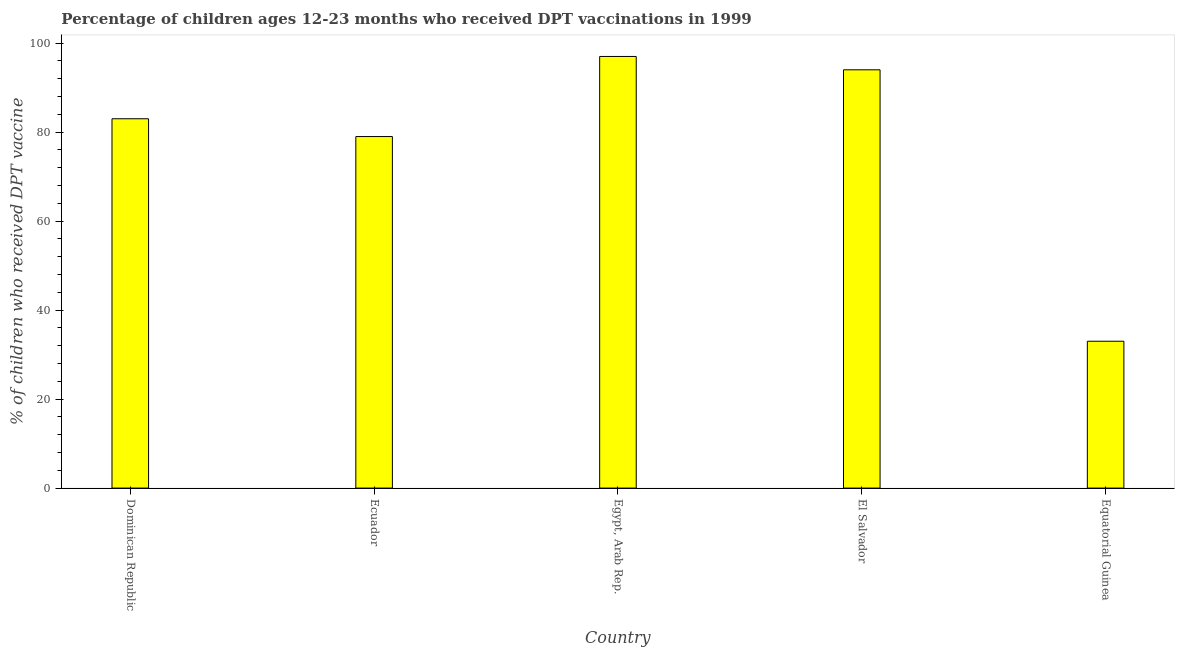Does the graph contain any zero values?
Make the answer very short. No. Does the graph contain grids?
Provide a short and direct response. No. What is the title of the graph?
Your answer should be very brief. Percentage of children ages 12-23 months who received DPT vaccinations in 1999. What is the label or title of the Y-axis?
Your answer should be compact. % of children who received DPT vaccine. What is the percentage of children who received dpt vaccine in Dominican Republic?
Offer a very short reply. 83. Across all countries, what is the maximum percentage of children who received dpt vaccine?
Make the answer very short. 97. Across all countries, what is the minimum percentage of children who received dpt vaccine?
Offer a very short reply. 33. In which country was the percentage of children who received dpt vaccine maximum?
Your answer should be compact. Egypt, Arab Rep. In which country was the percentage of children who received dpt vaccine minimum?
Make the answer very short. Equatorial Guinea. What is the sum of the percentage of children who received dpt vaccine?
Make the answer very short. 386. What is the average percentage of children who received dpt vaccine per country?
Offer a very short reply. 77.2. What is the ratio of the percentage of children who received dpt vaccine in Dominican Republic to that in Ecuador?
Your response must be concise. 1.05. Is the percentage of children who received dpt vaccine in Egypt, Arab Rep. less than that in El Salvador?
Keep it short and to the point. No. Is the sum of the percentage of children who received dpt vaccine in Ecuador and Egypt, Arab Rep. greater than the maximum percentage of children who received dpt vaccine across all countries?
Your response must be concise. Yes. In how many countries, is the percentage of children who received dpt vaccine greater than the average percentage of children who received dpt vaccine taken over all countries?
Provide a succinct answer. 4. Are all the bars in the graph horizontal?
Keep it short and to the point. No. What is the difference between two consecutive major ticks on the Y-axis?
Ensure brevity in your answer.  20. What is the % of children who received DPT vaccine in Ecuador?
Your response must be concise. 79. What is the % of children who received DPT vaccine in Egypt, Arab Rep.?
Offer a very short reply. 97. What is the % of children who received DPT vaccine of El Salvador?
Your answer should be very brief. 94. What is the difference between the % of children who received DPT vaccine in Dominican Republic and Ecuador?
Your response must be concise. 4. What is the difference between the % of children who received DPT vaccine in Dominican Republic and Egypt, Arab Rep.?
Provide a short and direct response. -14. What is the difference between the % of children who received DPT vaccine in Dominican Republic and El Salvador?
Your answer should be compact. -11. What is the difference between the % of children who received DPT vaccine in Ecuador and Egypt, Arab Rep.?
Ensure brevity in your answer.  -18. What is the difference between the % of children who received DPT vaccine in Egypt, Arab Rep. and El Salvador?
Make the answer very short. 3. What is the difference between the % of children who received DPT vaccine in Egypt, Arab Rep. and Equatorial Guinea?
Ensure brevity in your answer.  64. What is the ratio of the % of children who received DPT vaccine in Dominican Republic to that in Ecuador?
Your answer should be very brief. 1.05. What is the ratio of the % of children who received DPT vaccine in Dominican Republic to that in Egypt, Arab Rep.?
Ensure brevity in your answer.  0.86. What is the ratio of the % of children who received DPT vaccine in Dominican Republic to that in El Salvador?
Offer a very short reply. 0.88. What is the ratio of the % of children who received DPT vaccine in Dominican Republic to that in Equatorial Guinea?
Give a very brief answer. 2.52. What is the ratio of the % of children who received DPT vaccine in Ecuador to that in Egypt, Arab Rep.?
Your response must be concise. 0.81. What is the ratio of the % of children who received DPT vaccine in Ecuador to that in El Salvador?
Make the answer very short. 0.84. What is the ratio of the % of children who received DPT vaccine in Ecuador to that in Equatorial Guinea?
Provide a short and direct response. 2.39. What is the ratio of the % of children who received DPT vaccine in Egypt, Arab Rep. to that in El Salvador?
Provide a succinct answer. 1.03. What is the ratio of the % of children who received DPT vaccine in Egypt, Arab Rep. to that in Equatorial Guinea?
Your response must be concise. 2.94. What is the ratio of the % of children who received DPT vaccine in El Salvador to that in Equatorial Guinea?
Offer a very short reply. 2.85. 